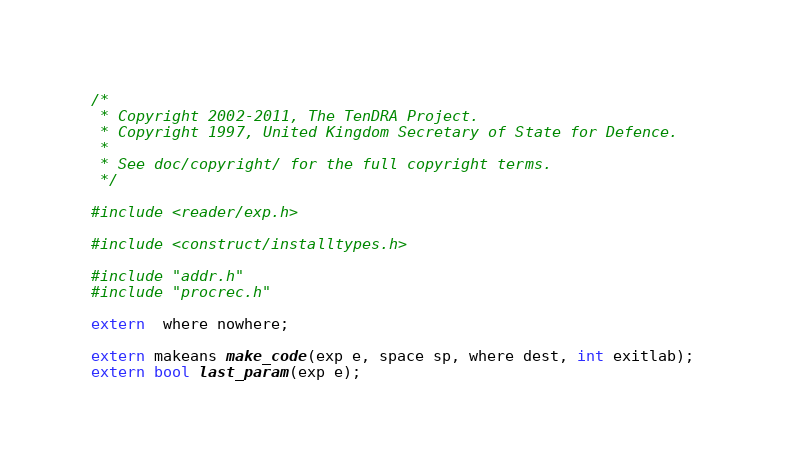<code> <loc_0><loc_0><loc_500><loc_500><_C_>/*
 * Copyright 2002-2011, The TenDRA Project.
 * Copyright 1997, United Kingdom Secretary of State for Defence.
 *
 * See doc/copyright/ for the full copyright terms.
 */

#include <reader/exp.h>

#include <construct/installtypes.h>

#include "addr.h"
#include "procrec.h"

extern  where nowhere;

extern makeans make_code(exp e, space sp, where dest, int exitlab);
extern bool last_param(exp e);

</code> 